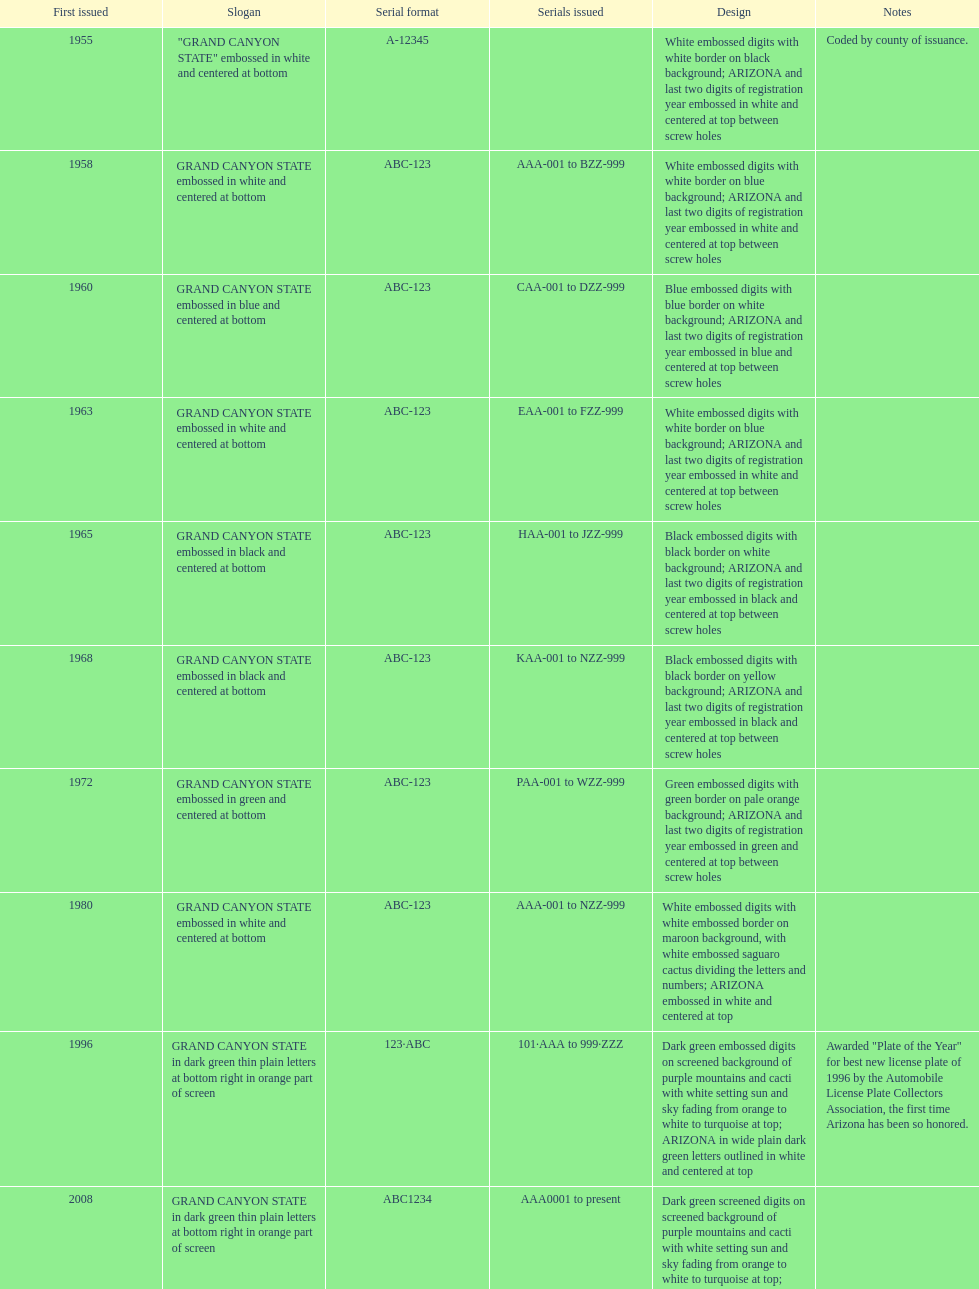Which year featured the license plate with the least characters? 1955. 